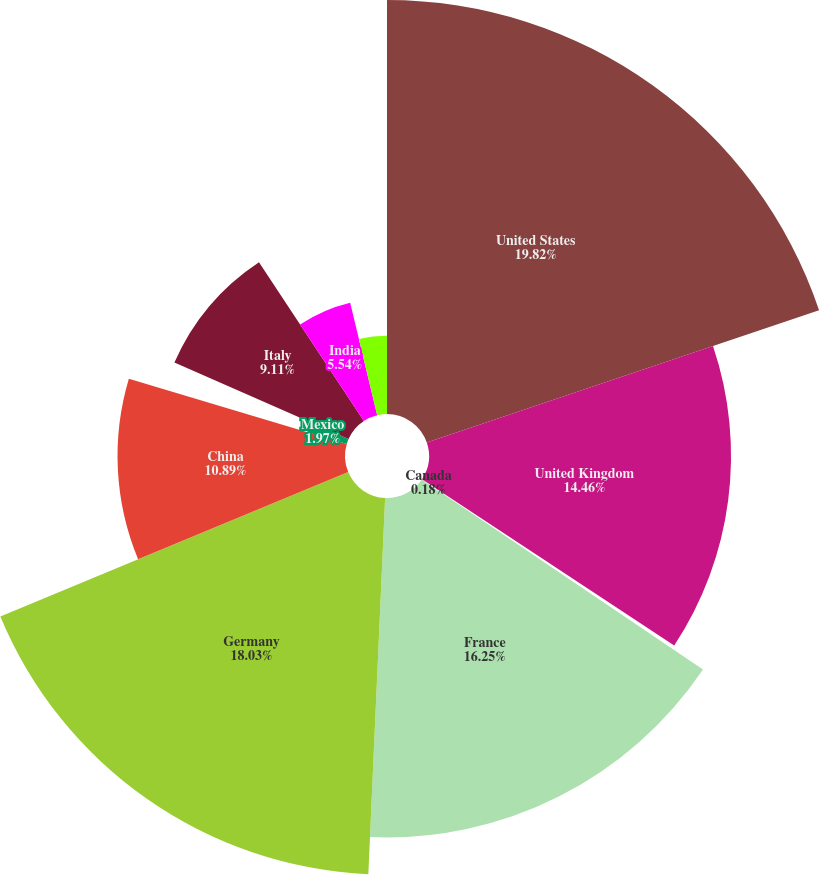<chart> <loc_0><loc_0><loc_500><loc_500><pie_chart><fcel>United States<fcel>United Kingdom<fcel>Canada<fcel>France<fcel>Germany<fcel>China<fcel>Mexico<fcel>Italy<fcel>India<fcel>Australia<nl><fcel>19.82%<fcel>14.46%<fcel>0.18%<fcel>16.25%<fcel>18.03%<fcel>10.89%<fcel>1.97%<fcel>9.11%<fcel>5.54%<fcel>3.75%<nl></chart> 